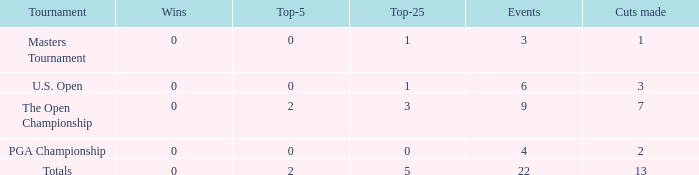What is the average number of cuts made for events with under 4 entries and more than 0 wins? None. 